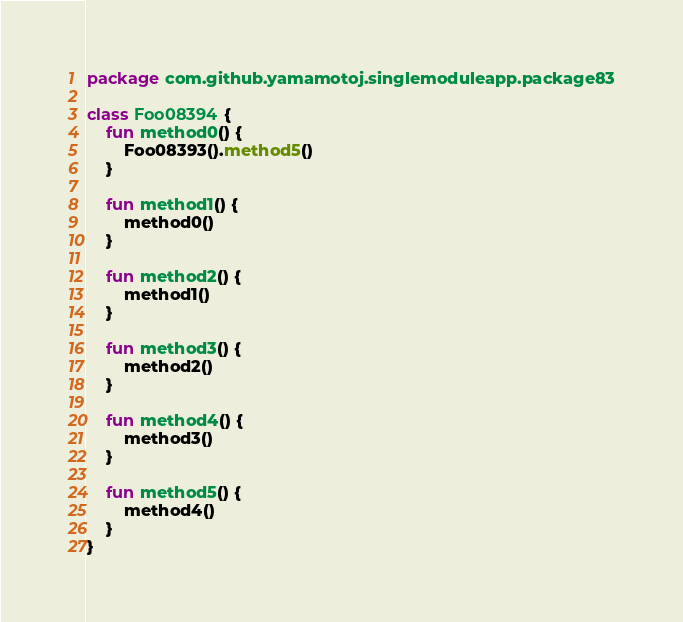Convert code to text. <code><loc_0><loc_0><loc_500><loc_500><_Kotlin_>package com.github.yamamotoj.singlemoduleapp.package83

class Foo08394 {
    fun method0() {
        Foo08393().method5()
    }

    fun method1() {
        method0()
    }

    fun method2() {
        method1()
    }

    fun method3() {
        method2()
    }

    fun method4() {
        method3()
    }

    fun method5() {
        method4()
    }
}
</code> 